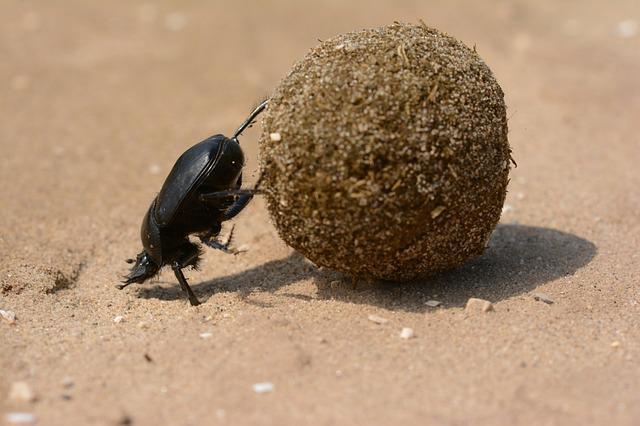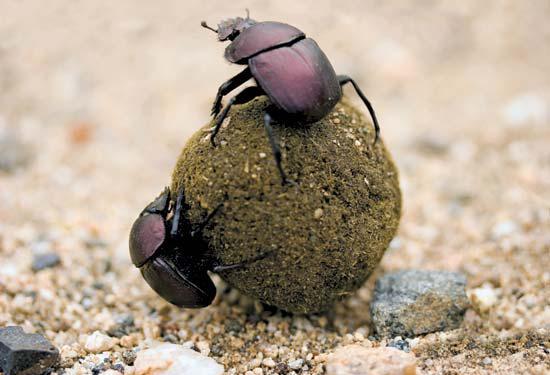The first image is the image on the left, the second image is the image on the right. Considering the images on both sides, is "There are two dung beetles in the image on the right." valid? Answer yes or no. Yes. The first image is the image on the left, the second image is the image on the right. Assess this claim about the two images: "There are at least three beetles.". Correct or not? Answer yes or no. Yes. 